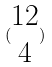<formula> <loc_0><loc_0><loc_500><loc_500>( \begin{matrix} 1 2 \\ 4 \end{matrix} )</formula> 